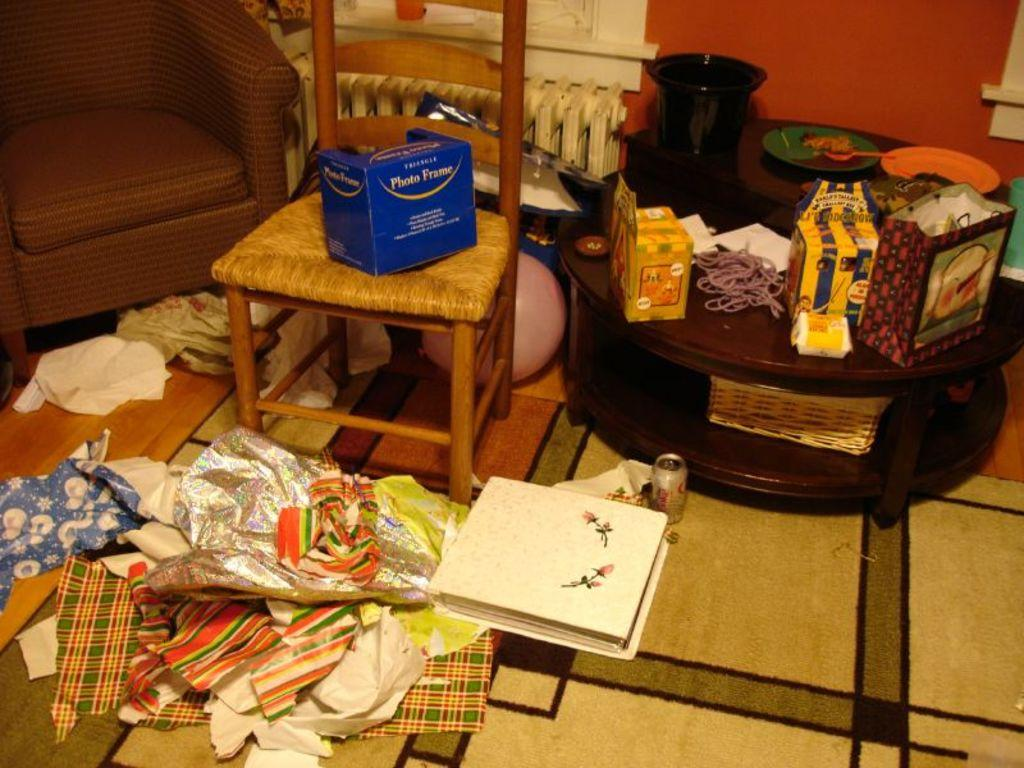What type of furniture is present in the room? There is a table, a chair, and a sofa in the room. What items are related to gift-giving in the room? There are gift wrappers in the room. What type of reading material is present in the room? There is a book in the room. What items are placed on the chair and table in the room? There is a box on the chair and a carry bag and another box on the table. What type of writing material is present on the table? There are papers on the table. What type of holiday is being celebrated in the room? There is no indication of a holiday being celebrated in the room. Can you see a train in the room? There is no train present in the room. 